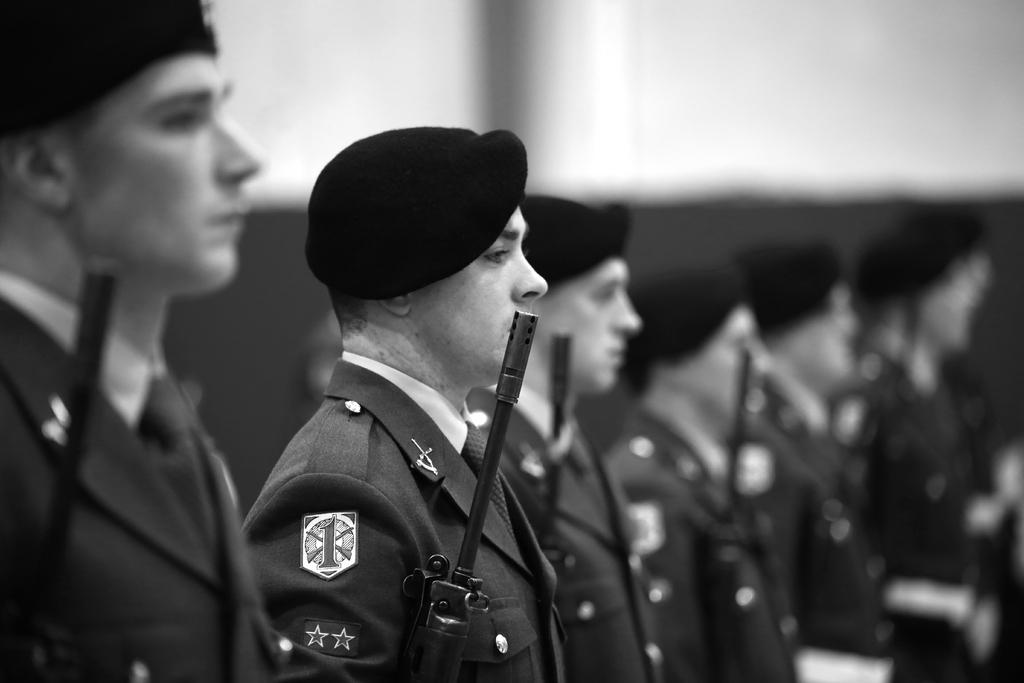What are the persons in the image doing? The persons in the image are standing and holding guns. What type of uniforms are the persons wearing? The persons are dressed as police officers. What type of headgear are the police officers wearing? The police officers are wearing caps. What can be seen in the background of the image? There is a wall in the background of the image. What type of taste does the writer in the image prefer? There is no writer present in the image, so it is not possible to determine their taste preferences. 